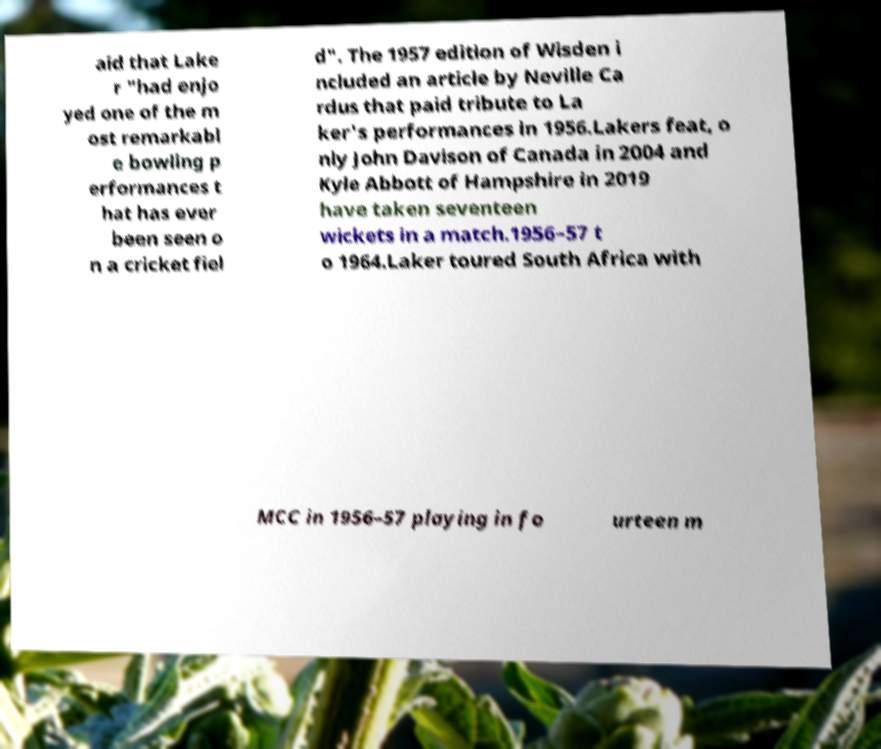Can you read and provide the text displayed in the image?This photo seems to have some interesting text. Can you extract and type it out for me? aid that Lake r "had enjo yed one of the m ost remarkabl e bowling p erformances t hat has ever been seen o n a cricket fiel d". The 1957 edition of Wisden i ncluded an article by Neville Ca rdus that paid tribute to La ker's performances in 1956.Lakers feat, o nly John Davison of Canada in 2004 and Kyle Abbott of Hampshire in 2019 have taken seventeen wickets in a match.1956–57 t o 1964.Laker toured South Africa with MCC in 1956–57 playing in fo urteen m 